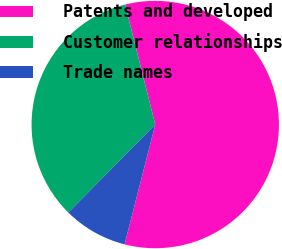Convert chart to OTSL. <chart><loc_0><loc_0><loc_500><loc_500><pie_chart><fcel>Patents and developed<fcel>Customer relationships<fcel>Trade names<nl><fcel>57.91%<fcel>33.67%<fcel>8.42%<nl></chart> 